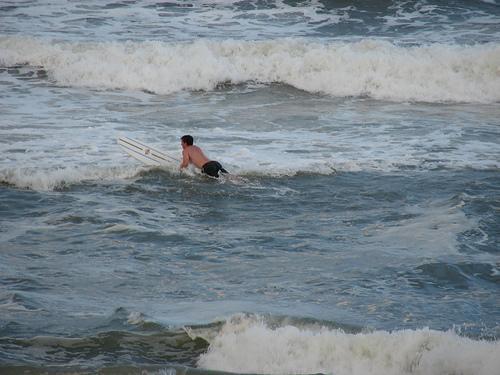How many people are in the photo?
Give a very brief answer. 1. 